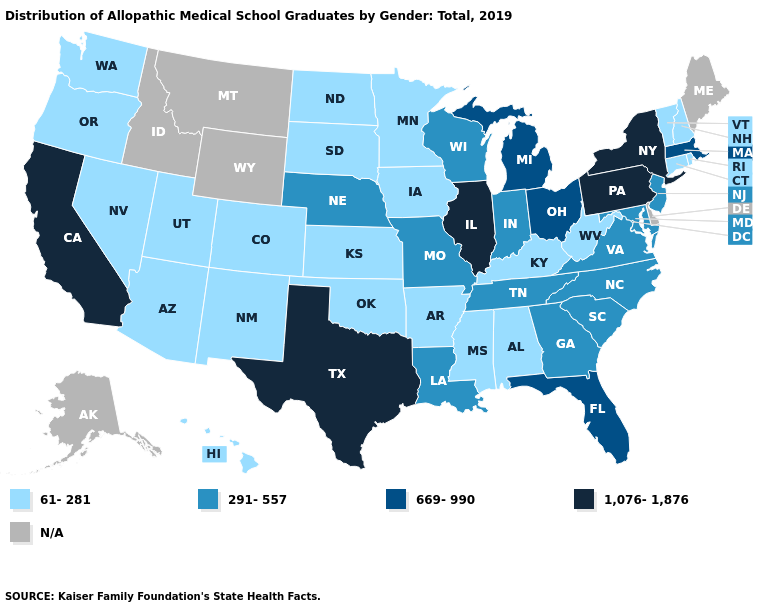What is the highest value in the USA?
Short answer required. 1,076-1,876. Does Rhode Island have the lowest value in the Northeast?
Write a very short answer. Yes. Which states have the highest value in the USA?
Give a very brief answer. California, Illinois, New York, Pennsylvania, Texas. What is the highest value in the USA?
Keep it brief. 1,076-1,876. Name the states that have a value in the range 669-990?
Short answer required. Florida, Massachusetts, Michigan, Ohio. Which states have the highest value in the USA?
Keep it brief. California, Illinois, New York, Pennsylvania, Texas. What is the lowest value in the USA?
Quick response, please. 61-281. How many symbols are there in the legend?
Keep it brief. 5. Name the states that have a value in the range 1,076-1,876?
Give a very brief answer. California, Illinois, New York, Pennsylvania, Texas. Name the states that have a value in the range N/A?
Write a very short answer. Alaska, Delaware, Idaho, Maine, Montana, Wyoming. Which states have the lowest value in the USA?
Be succinct. Alabama, Arizona, Arkansas, Colorado, Connecticut, Hawaii, Iowa, Kansas, Kentucky, Minnesota, Mississippi, Nevada, New Hampshire, New Mexico, North Dakota, Oklahoma, Oregon, Rhode Island, South Dakota, Utah, Vermont, Washington, West Virginia. What is the lowest value in the USA?
Concise answer only. 61-281. Name the states that have a value in the range N/A?
Be succinct. Alaska, Delaware, Idaho, Maine, Montana, Wyoming. What is the lowest value in the USA?
Keep it brief. 61-281. Does the first symbol in the legend represent the smallest category?
Give a very brief answer. Yes. 